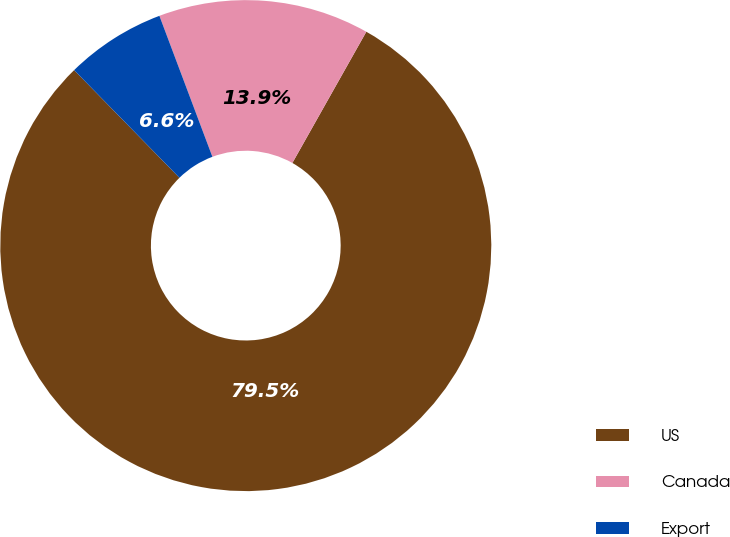Convert chart to OTSL. <chart><loc_0><loc_0><loc_500><loc_500><pie_chart><fcel>US<fcel>Canada<fcel>Export<nl><fcel>79.5%<fcel>13.89%<fcel>6.6%<nl></chart> 